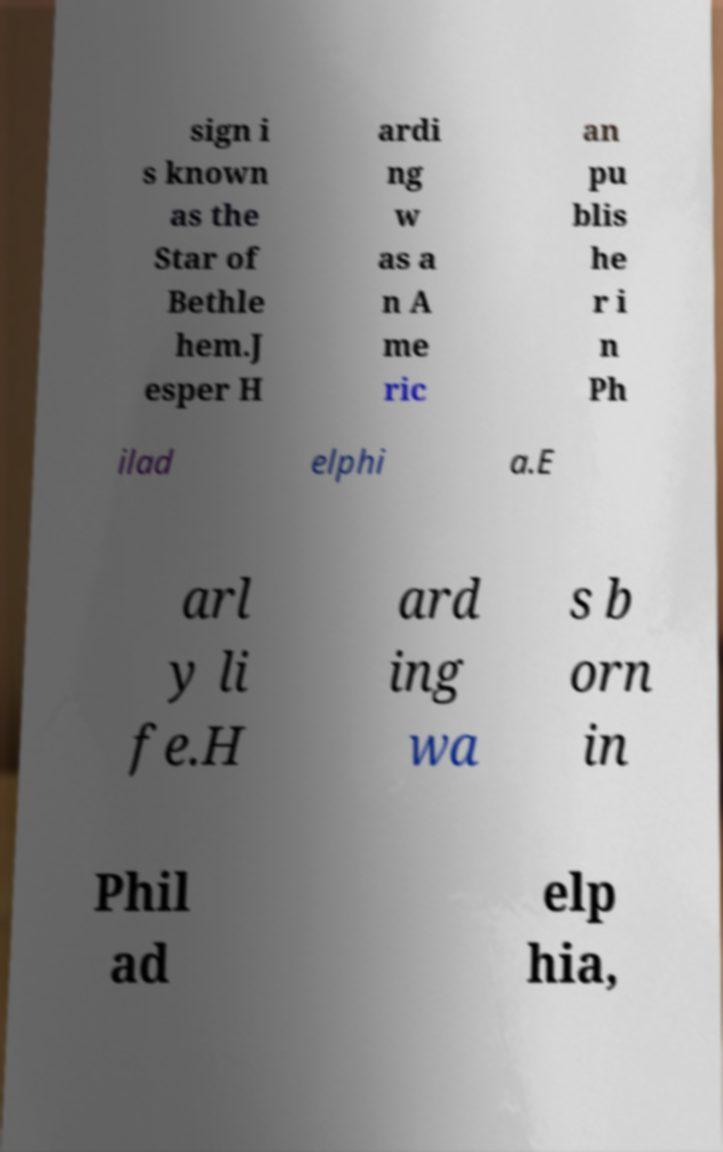Can you accurately transcribe the text from the provided image for me? sign i s known as the Star of Bethle hem.J esper H ardi ng w as a n A me ric an pu blis he r i n Ph ilad elphi a.E arl y li fe.H ard ing wa s b orn in Phil ad elp hia, 